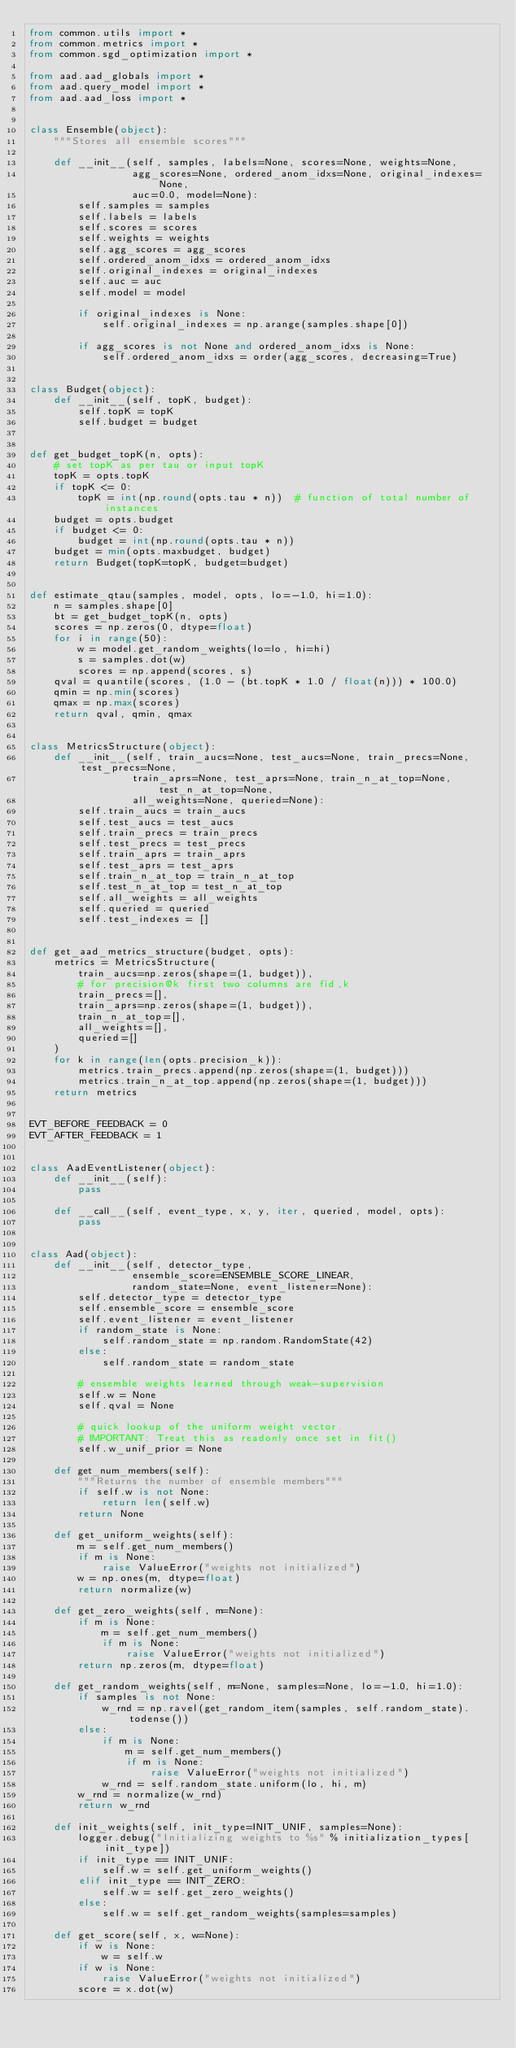Convert code to text. <code><loc_0><loc_0><loc_500><loc_500><_Python_>from common.utils import *
from common.metrics import *
from common.sgd_optimization import *

from aad.aad_globals import *
from aad.query_model import *
from aad.aad_loss import *


class Ensemble(object):
    """Stores all ensemble scores"""

    def __init__(self, samples, labels=None, scores=None, weights=None,
                 agg_scores=None, ordered_anom_idxs=None, original_indexes=None,
                 auc=0.0, model=None):
        self.samples = samples
        self.labels = labels
        self.scores = scores
        self.weights = weights
        self.agg_scores = agg_scores
        self.ordered_anom_idxs = ordered_anom_idxs
        self.original_indexes = original_indexes
        self.auc = auc
        self.model = model

        if original_indexes is None:
            self.original_indexes = np.arange(samples.shape[0])

        if agg_scores is not None and ordered_anom_idxs is None:
            self.ordered_anom_idxs = order(agg_scores, decreasing=True)


class Budget(object):
    def __init__(self, topK, budget):
        self.topK = topK
        self.budget = budget


def get_budget_topK(n, opts):
    # set topK as per tau or input topK
    topK = opts.topK
    if topK <= 0:
        topK = int(np.round(opts.tau * n))  # function of total number of instances
    budget = opts.budget
    if budget <= 0:
        budget = int(np.round(opts.tau * n))
    budget = min(opts.maxbudget, budget)
    return Budget(topK=topK, budget=budget)


def estimate_qtau(samples, model, opts, lo=-1.0, hi=1.0):
    n = samples.shape[0]
    bt = get_budget_topK(n, opts)
    scores = np.zeros(0, dtype=float)
    for i in range(50):
        w = model.get_random_weights(lo=lo, hi=hi)
        s = samples.dot(w)
        scores = np.append(scores, s)
    qval = quantile(scores, (1.0 - (bt.topK * 1.0 / float(n))) * 100.0)
    qmin = np.min(scores)
    qmax = np.max(scores)
    return qval, qmin, qmax


class MetricsStructure(object):
    def __init__(self, train_aucs=None, test_aucs=None, train_precs=None, test_precs=None,
                 train_aprs=None, test_aprs=None, train_n_at_top=None, test_n_at_top=None,
                 all_weights=None, queried=None):
        self.train_aucs = train_aucs
        self.test_aucs = test_aucs
        self.train_precs = train_precs
        self.test_precs = test_precs
        self.train_aprs = train_aprs
        self.test_aprs = test_aprs
        self.train_n_at_top = train_n_at_top
        self.test_n_at_top = test_n_at_top
        self.all_weights = all_weights
        self.queried = queried
        self.test_indexes = []


def get_aad_metrics_structure(budget, opts):
    metrics = MetricsStructure(
        train_aucs=np.zeros(shape=(1, budget)),
        # for precision@k first two columns are fid,k
        train_precs=[],
        train_aprs=np.zeros(shape=(1, budget)),
        train_n_at_top=[],
        all_weights=[],
        queried=[]
    )
    for k in range(len(opts.precision_k)):
        metrics.train_precs.append(np.zeros(shape=(1, budget)))
        metrics.train_n_at_top.append(np.zeros(shape=(1, budget)))
    return metrics


EVT_BEFORE_FEEDBACK = 0
EVT_AFTER_FEEDBACK = 1


class AadEventListener(object):
    def __init__(self):
        pass

    def __call__(self, event_type, x, y, iter, queried, model, opts):
        pass


class Aad(object):
    def __init__(self, detector_type,
                 ensemble_score=ENSEMBLE_SCORE_LINEAR,
                 random_state=None, event_listener=None):
        self.detector_type = detector_type
        self.ensemble_score = ensemble_score
        self.event_listener = event_listener
        if random_state is None:
            self.random_state = np.random.RandomState(42)
        else:
            self.random_state = random_state

        # ensemble weights learned through weak-supervision
        self.w = None
        self.qval = None

        # quick lookup of the uniform weight vector.
        # IMPORTANT: Treat this as readonly once set in fit()
        self.w_unif_prior = None

    def get_num_members(self):
        """Returns the number of ensemble members"""
        if self.w is not None:
            return len(self.w)
        return None

    def get_uniform_weights(self):
        m = self.get_num_members()
        if m is None:
            raise ValueError("weights not initialized")
        w = np.ones(m, dtype=float)
        return normalize(w)

    def get_zero_weights(self, m=None):
        if m is None:
            m = self.get_num_members()
            if m is None:
                raise ValueError("weights not initialized")
        return np.zeros(m, dtype=float)

    def get_random_weights(self, m=None, samples=None, lo=-1.0, hi=1.0):
        if samples is not None:
            w_rnd = np.ravel(get_random_item(samples, self.random_state).todense())
        else:
            if m is None:
                m = self.get_num_members()
                if m is None:
                    raise ValueError("weights not initialized")
            w_rnd = self.random_state.uniform(lo, hi, m)
        w_rnd = normalize(w_rnd)
        return w_rnd

    def init_weights(self, init_type=INIT_UNIF, samples=None):
        logger.debug("Initializing weights to %s" % initialization_types[init_type])
        if init_type == INIT_UNIF:
            self.w = self.get_uniform_weights()
        elif init_type == INIT_ZERO:
            self.w = self.get_zero_weights()
        else:
            self.w = self.get_random_weights(samples=samples)

    def get_score(self, x, w=None):
        if w is None:
            w = self.w
        if w is None:
            raise ValueError("weights not initialized")
        score = x.dot(w)</code> 